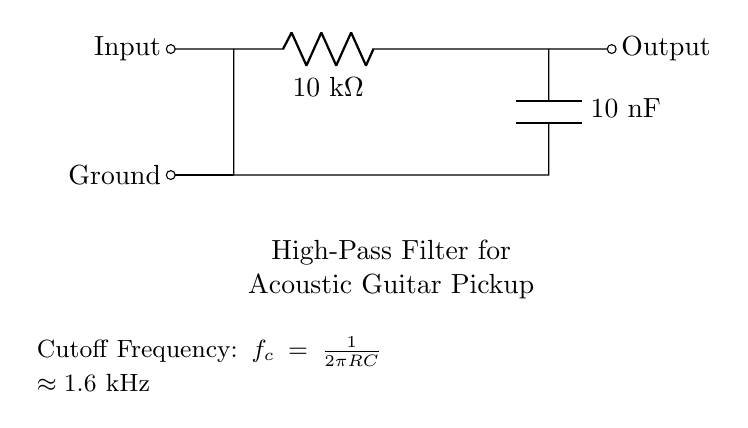What is the resistance value in the circuit? The resistance is labeled as R, and the specified value in the diagram is 10 kΩ. This can be read directly from the circuit component label.
Answer: 10 kΩ What type of filter is represented in this circuit? The circuit diagram clearly indicates that it is a high-pass filter, as its primary purpose is to allow high frequencies to pass while attenuating lower frequencies. This is supported by the arrangement of the components.
Answer: High-pass filter What is the capacitance value in the circuit? The capacitance is labeled as C, which has a value of 10 nF as shown in the diagram. This information is directly indicated on the capacitor component.
Answer: 10 nF What is the cutoff frequency of this filter? The cutoff frequency formula is given in the diagram as \( f_c = \frac{1}{2\pi RC} \), and calculated to be approximately 1.6 kHz based on the specified resistance and capacitance values. Substituting the values, we can derive this frequency.
Answer: 1.6 kHz Which component is responsible for allowing high frequencies to pass through? The capacitor is the component that allows high frequencies to pass. In a high-pass filter, the capacitor blocks low frequencies and allows high frequencies to continue through the output.
Answer: Capacitor What happens to low frequencies in this circuit? Low frequencies are attenuated in this high-pass filter. The design of the circuit, particularly due to the presence of the capacitor in series with the resistor, prevents low-frequency signals from gaining significant output.
Answer: Attenuated What is the role of the resistor in this circuit? The resistor works in conjunction with the capacitor to determine the cutoff frequency of the filter, influencing how quickly the output level drops for signals below the cutoff frequency. It helps shape the frequency response of the filter.
Answer: Determine cutoff frequency 